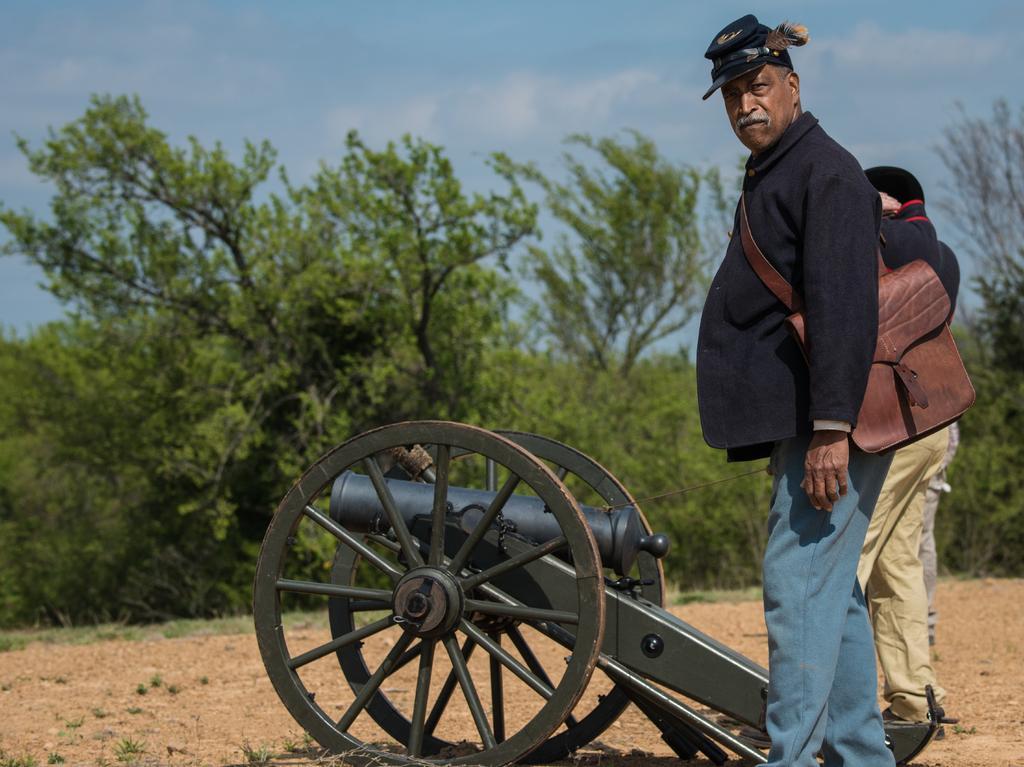Could you give a brief overview of what you see in this image? In this image I can see few people standing in-front of the cannon. I can see one person wearing the brown color bag. In the background I can see many trees and the sky. 